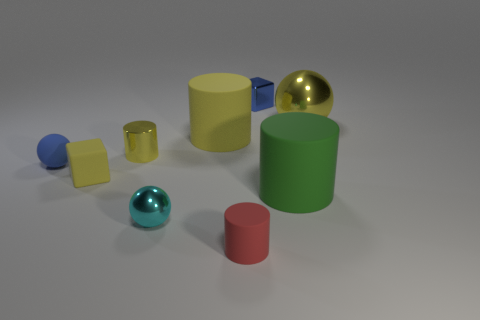There is a matte block; is it the same color as the metal sphere right of the green matte cylinder?
Your answer should be very brief. Yes. What number of other objects are there of the same color as the big ball?
Offer a very short reply. 3. Is the number of red balls less than the number of tiny blue matte objects?
Your answer should be compact. Yes. There is a large rubber thing on the left side of the tiny rubber object in front of the green cylinder; what number of small metal cylinders are to the right of it?
Offer a terse response. 0. There is a cyan object that is left of the tiny blue metallic thing; what size is it?
Your answer should be very brief. Small. There is a small metallic thing in front of the tiny blue matte object; is its shape the same as the small blue rubber object?
Your response must be concise. Yes. What material is the other thing that is the same shape as the small yellow rubber object?
Provide a short and direct response. Metal. Are there any other things that have the same size as the cyan sphere?
Give a very brief answer. Yes. Are there any large purple blocks?
Your response must be concise. No. What material is the ball in front of the block to the left of the big rubber cylinder that is behind the small blue matte ball?
Provide a succinct answer. Metal. 